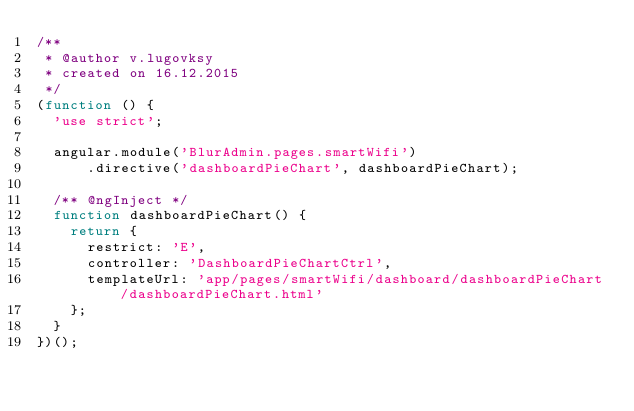<code> <loc_0><loc_0><loc_500><loc_500><_JavaScript_>/**
 * @author v.lugovksy
 * created on 16.12.2015
 */
(function () {
  'use strict';

  angular.module('BlurAdmin.pages.smartWifi')
      .directive('dashboardPieChart', dashboardPieChart);

  /** @ngInject */
  function dashboardPieChart() {
    return {
      restrict: 'E',
      controller: 'DashboardPieChartCtrl',
      templateUrl: 'app/pages/smartWifi/dashboard/dashboardPieChart/dashboardPieChart.html'
    };
  }
})();</code> 